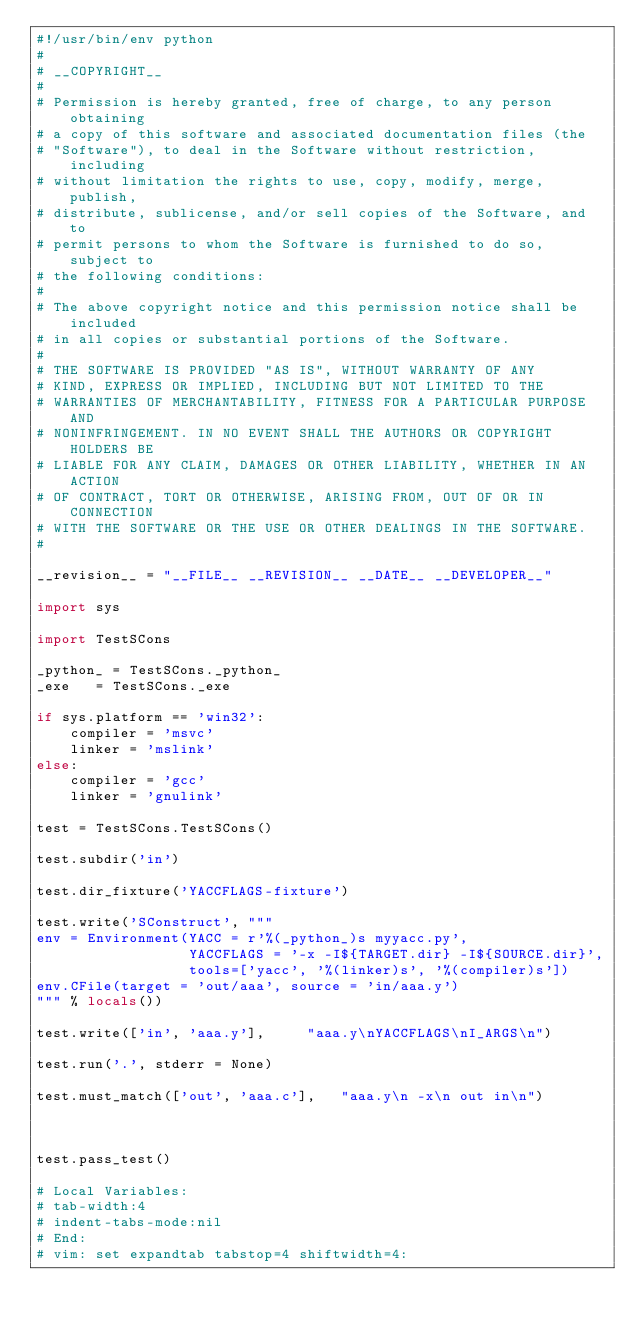Convert code to text. <code><loc_0><loc_0><loc_500><loc_500><_Python_>#!/usr/bin/env python
#
# __COPYRIGHT__
#
# Permission is hereby granted, free of charge, to any person obtaining
# a copy of this software and associated documentation files (the
# "Software"), to deal in the Software without restriction, including
# without limitation the rights to use, copy, modify, merge, publish,
# distribute, sublicense, and/or sell copies of the Software, and to
# permit persons to whom the Software is furnished to do so, subject to
# the following conditions:
#
# The above copyright notice and this permission notice shall be included
# in all copies or substantial portions of the Software.
#
# THE SOFTWARE IS PROVIDED "AS IS", WITHOUT WARRANTY OF ANY
# KIND, EXPRESS OR IMPLIED, INCLUDING BUT NOT LIMITED TO THE
# WARRANTIES OF MERCHANTABILITY, FITNESS FOR A PARTICULAR PURPOSE AND
# NONINFRINGEMENT. IN NO EVENT SHALL THE AUTHORS OR COPYRIGHT HOLDERS BE
# LIABLE FOR ANY CLAIM, DAMAGES OR OTHER LIABILITY, WHETHER IN AN ACTION
# OF CONTRACT, TORT OR OTHERWISE, ARISING FROM, OUT OF OR IN CONNECTION
# WITH THE SOFTWARE OR THE USE OR OTHER DEALINGS IN THE SOFTWARE.
#

__revision__ = "__FILE__ __REVISION__ __DATE__ __DEVELOPER__"

import sys

import TestSCons

_python_ = TestSCons._python_
_exe   = TestSCons._exe

if sys.platform == 'win32':
    compiler = 'msvc'
    linker = 'mslink'
else:
    compiler = 'gcc'
    linker = 'gnulink'

test = TestSCons.TestSCons()

test.subdir('in')

test.dir_fixture('YACCFLAGS-fixture')

test.write('SConstruct', """
env = Environment(YACC = r'%(_python_)s myyacc.py',
                  YACCFLAGS = '-x -I${TARGET.dir} -I${SOURCE.dir}',
                  tools=['yacc', '%(linker)s', '%(compiler)s'])
env.CFile(target = 'out/aaa', source = 'in/aaa.y')
""" % locals())

test.write(['in', 'aaa.y'],		"aaa.y\nYACCFLAGS\nI_ARGS\n")

test.run('.', stderr = None)

test.must_match(['out', 'aaa.c'],	"aaa.y\n -x\n out in\n")



test.pass_test()

# Local Variables:
# tab-width:4
# indent-tabs-mode:nil
# End:
# vim: set expandtab tabstop=4 shiftwidth=4:
</code> 